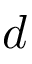Convert formula to latex. <formula><loc_0><loc_0><loc_500><loc_500>d</formula> 